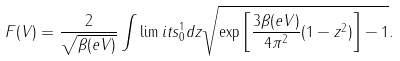Convert formula to latex. <formula><loc_0><loc_0><loc_500><loc_500>F ( V ) = \frac { 2 } { \sqrt { \beta ( e V ) } } \int \lim i t s _ { 0 } ^ { 1 } d z \sqrt { \exp { \left [ \frac { 3 \beta ( e V ) } { 4 \pi ^ { 2 } } ( 1 - z ^ { 2 } ) \right ] } - 1 } .</formula> 